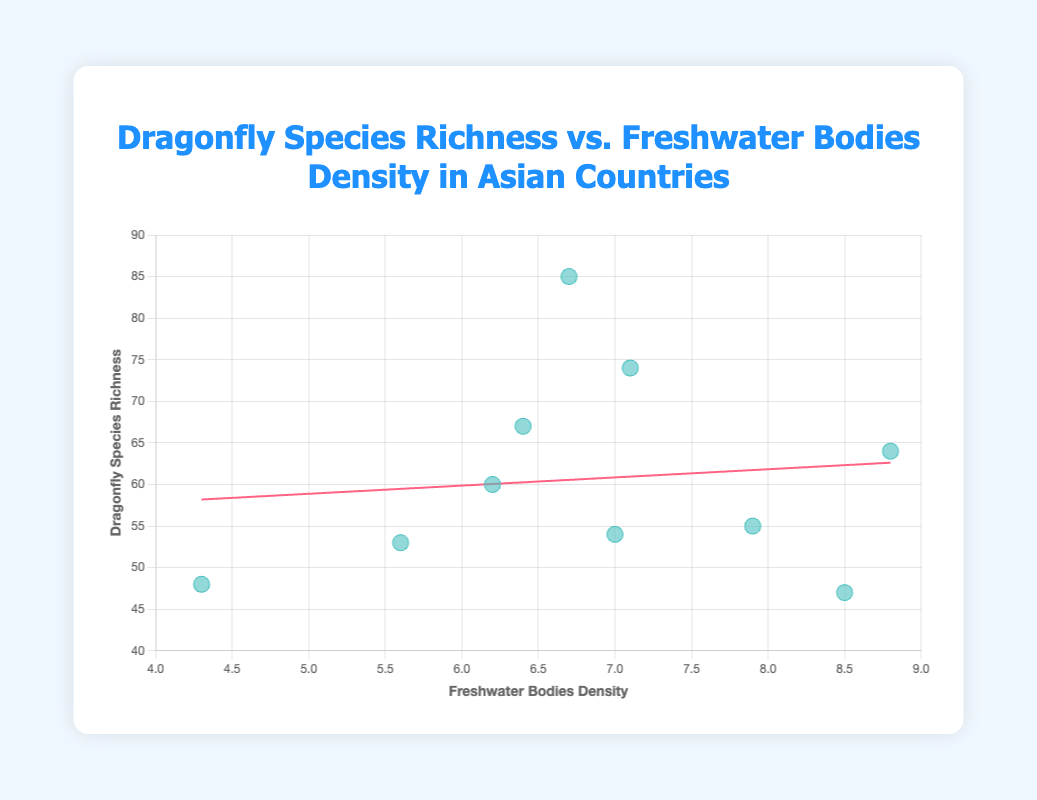How many data points are shown in the scatter plot? There are 10 countries in the provided data, and each country is represented by a single data point in the scatter plot.
Answer: 10 What is the title of the chart? The title of the chart is displayed at the top of the figure.
Answer: "Dragonfly Species Richness vs. Freshwater Bodies Density in Asian Countries" Which country has the highest dragonfly species richness? By looking at the vertical axis (Dragonfly Species Richness) and identifying the point with the highest y-value, we see that India has the highest value at 85.
Answer: India What range does the x-axis cover for the density of freshwater bodies? The x-axis represents Freshwater Bodies Density and it ranges from 4 to 9.
Answer: 4 to 9 What is the general trend between dragonfly species richness and freshwater bodies density? The trend line indicates a positive relationship, meaning dragonfly species richness increases with higher freshwater bodies density.
Answer: Positive Which country has the lowest density of freshwater bodies? By observing the horizontal axis (Freshwater Bodies Density) and identifying the lowest x-value, the Philippines has the lowest value at 4.3.
Answer: Philippines What is the median freshwater bodies density value among these countries? To find the median, the density values are sorted: 4.3, 5.6, 6.2, 6.4, 6.7, 7.0, 7.1, 7.9, 8.5, 8.8. The middle values are 6.7 and 7.0, so the median is (6.7 + 7.0)/2 = 6.85.
Answer: 6.85 Which country is closest to the average dragonfly species richness? The average dragonfly species richness is calculated by summing all y-values and dividing by the number of data points: (47 + 85 + 74 + 64 + 55 + 60 + 67 + 48 + 54 + 53)/10 = 60.7. Thailand is closest with a richness of 64.
Answer: Thailand How does the species richness of Vietnam compare to that of Nepal? The y-values for Vietnam and Nepal are 55 and 54, respectively. Vietnam has a slighty higher species richness than Nepal.
Answer: Vietnam Which countries have a freshwater bodies density greater than 7.5? The countries with density values greater than 7.5 are Japan (8.5), Thailand (8.8), and Vietnam (7.9).
Answer: Japan, Thailand, Vietnam 